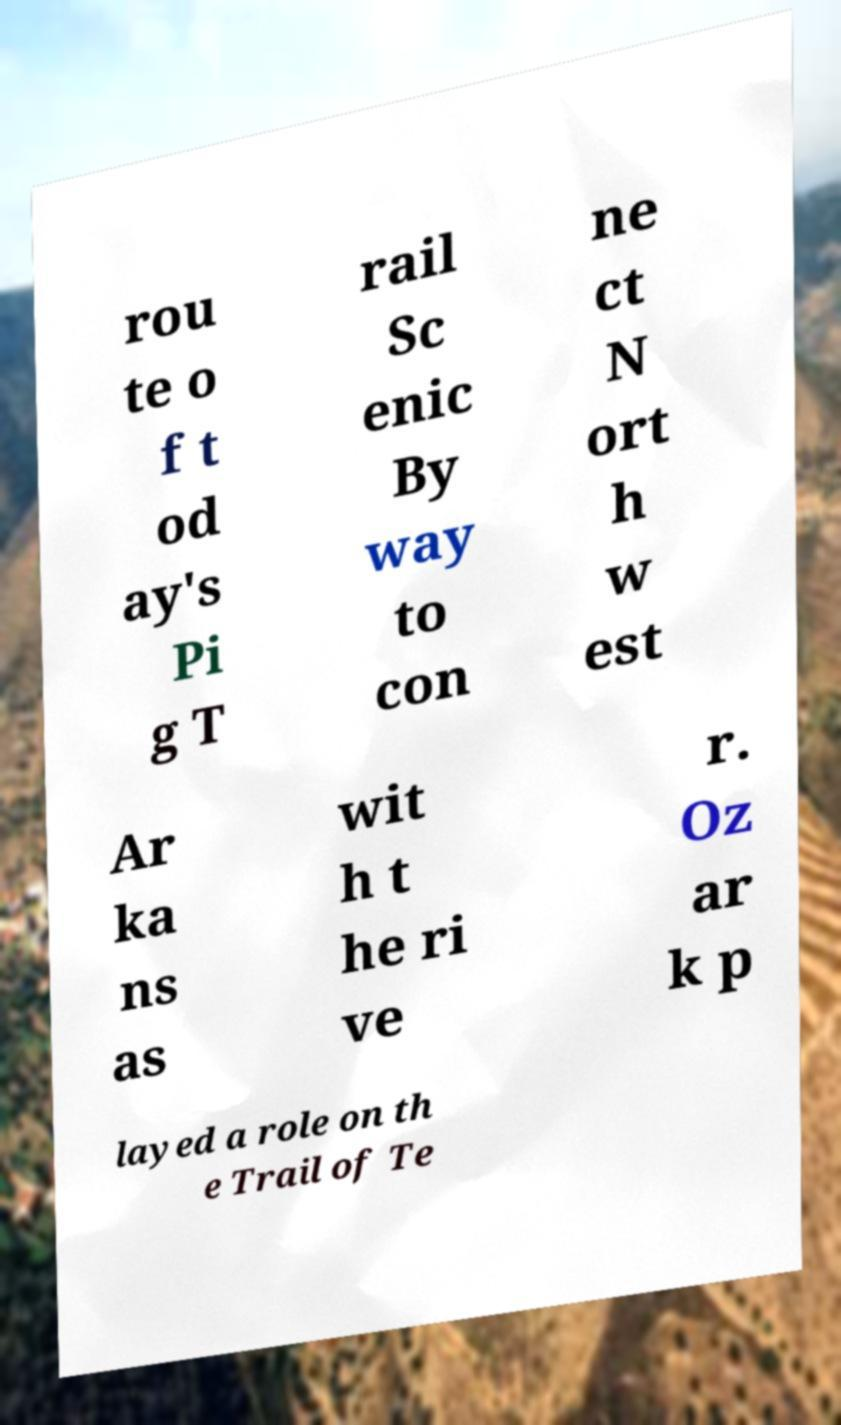Could you extract and type out the text from this image? rou te o f t od ay's Pi g T rail Sc enic By way to con ne ct N ort h w est Ar ka ns as wit h t he ri ve r. Oz ar k p layed a role on th e Trail of Te 